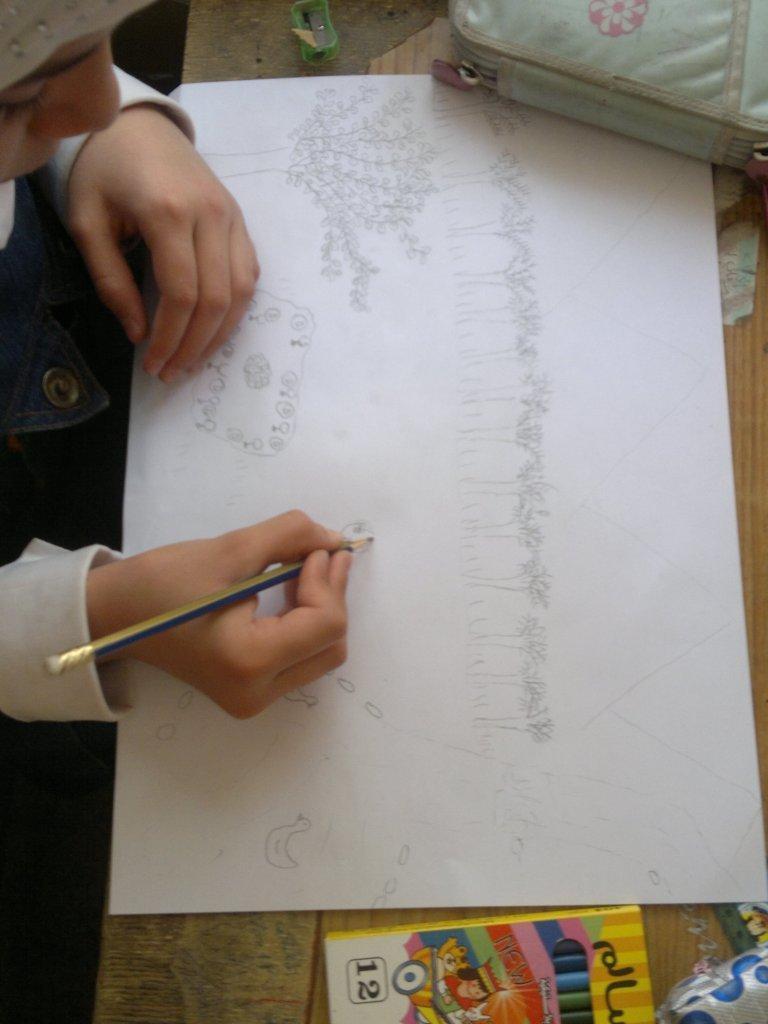In one or two sentences, can you explain what this image depicts? On the right side of the image we can see table, on the table we can see a paper, bag and we can see a pencil box. On the left side of the image a girl is sitting and holding a pencil and drawing. 